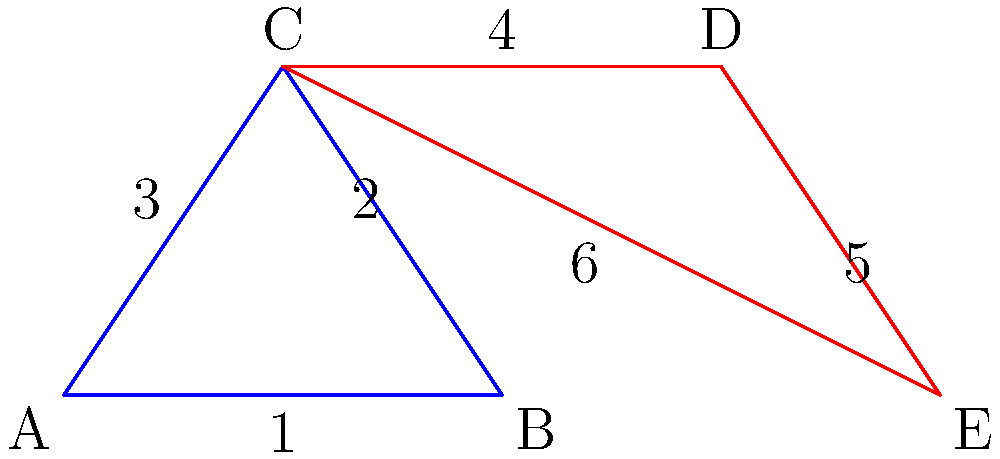In your travel itinerary map, two triangles represent different route options. Which two sides, one from each triangle, must be proven congruent to establish that these triangles are congruent by the SAS (Side-Angle-Side) criterion? To prove that the triangles are congruent using the SAS criterion, we need to establish:

1. Two pairs of congruent sides (one pair given, one to be found)
2. The included angles between these sides are congruent

Step 1: Identify the given congruent sides
- Side 3 (AC) in the blue triangle and side 6 (CE) in the red triangle are clearly the same length as they share point C.

Step 2: Identify the included angle
- Angle C is common to both triangles, so it's the included angle between the congruent sides.

Step 3: Determine the other pair of sides that need to be congruent
- For SAS, we need the sides adjacent to angle C in both triangles to be congruent.
- In the blue triangle, this is side 2 (BC).
- In the red triangle, this is side 4 (CD).

Therefore, to prove these triangles are congruent by SAS, we need to show that side 2 (BC) is congruent to side 4 (CD).
Answer: Side 2 and Side 4 